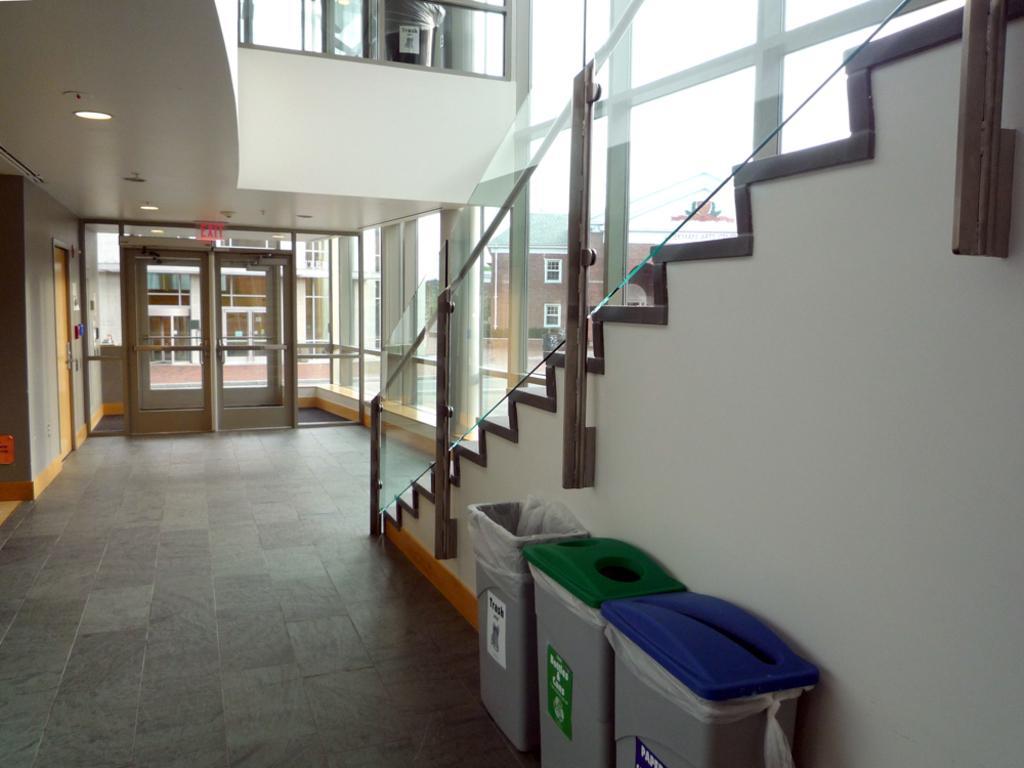Could you give a brief overview of what you see in this image? In this image, we can see the floor, we can see dustbins and there are some stairs and we can see railing, we can see the glass door and we can see the wall. 